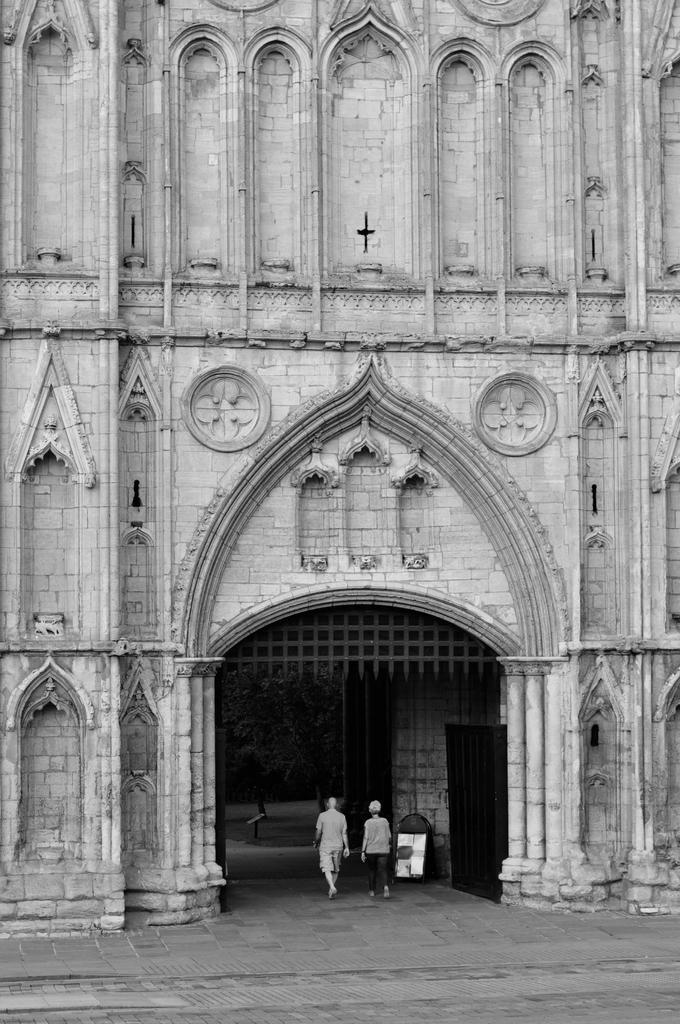What is the color scheme of the image? The image is black and white. What can be seen at the foreground of the image? There are persons at the entrance in the image. What is visible in the background of the image? There is a building in the background of the image. Reasoning: Let's think step by step by step in order to produce the conversation. We start by identifying the color scheme of the image, which is black and white. Then, we focus on the foreground and background of the image, describing the main subjects and objects present. We ensure that each question can be answered definitively with the information given and avoid yes/no questions. Absurd Question/Answer: What type of oatmeal is being served at the entrance in the image? There is no oatmeal present in the image; it is a black and white image featuring persons at the entrance of a building. Can you see any fangs on the persons at the entrance in the image? There are no fangs visible on the persons at the entrance in the image. 